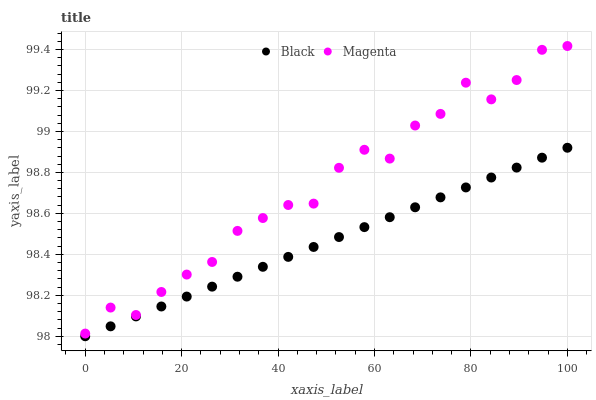Does Black have the minimum area under the curve?
Answer yes or no. Yes. Does Magenta have the maximum area under the curve?
Answer yes or no. Yes. Does Black have the maximum area under the curve?
Answer yes or no. No. Is Black the smoothest?
Answer yes or no. Yes. Is Magenta the roughest?
Answer yes or no. Yes. Is Black the roughest?
Answer yes or no. No. Does Black have the lowest value?
Answer yes or no. Yes. Does Magenta have the highest value?
Answer yes or no. Yes. Does Black have the highest value?
Answer yes or no. No. Is Black less than Magenta?
Answer yes or no. Yes. Is Magenta greater than Black?
Answer yes or no. Yes. Does Black intersect Magenta?
Answer yes or no. No. 